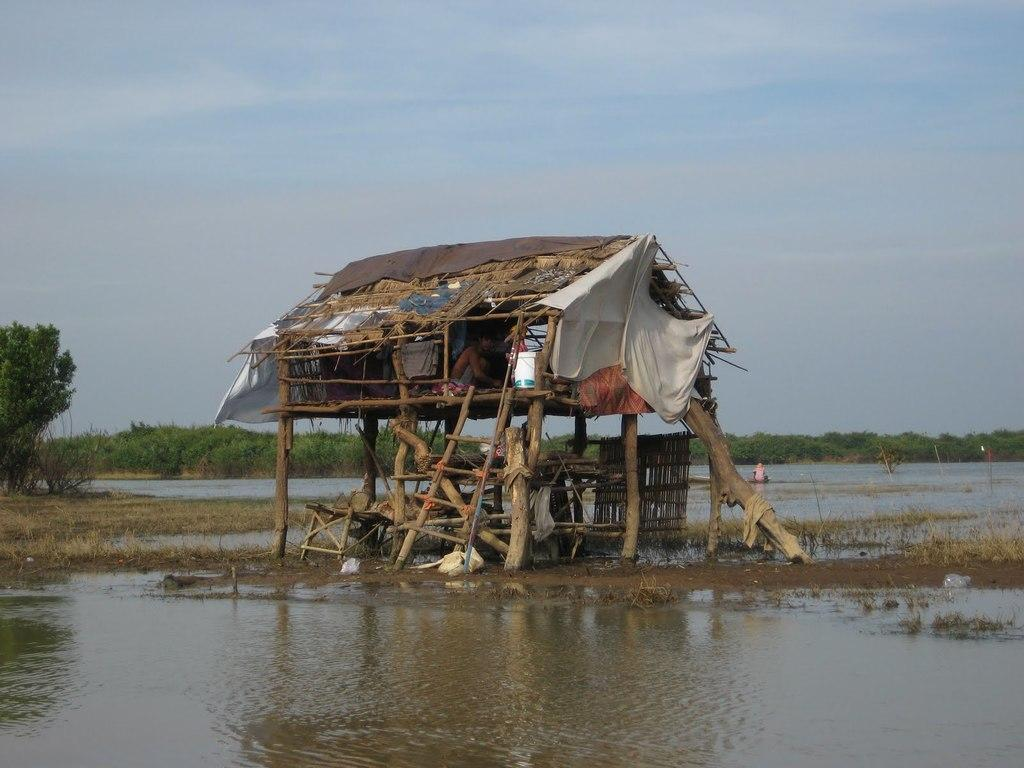What is present in the image that is not solid? There is water in the image. What type of structure can be seen in the image? There is a shack in the image. Can you describe the person in the image? There is a person in the image. What can be seen in the background of the image? There are trees and the sky visible in the background of the image. What type of canvas is the person painting in the image? There is no canvas or painting activity present in the image. Can you describe the bat that is flying in the image? There is no bat present in the image. 